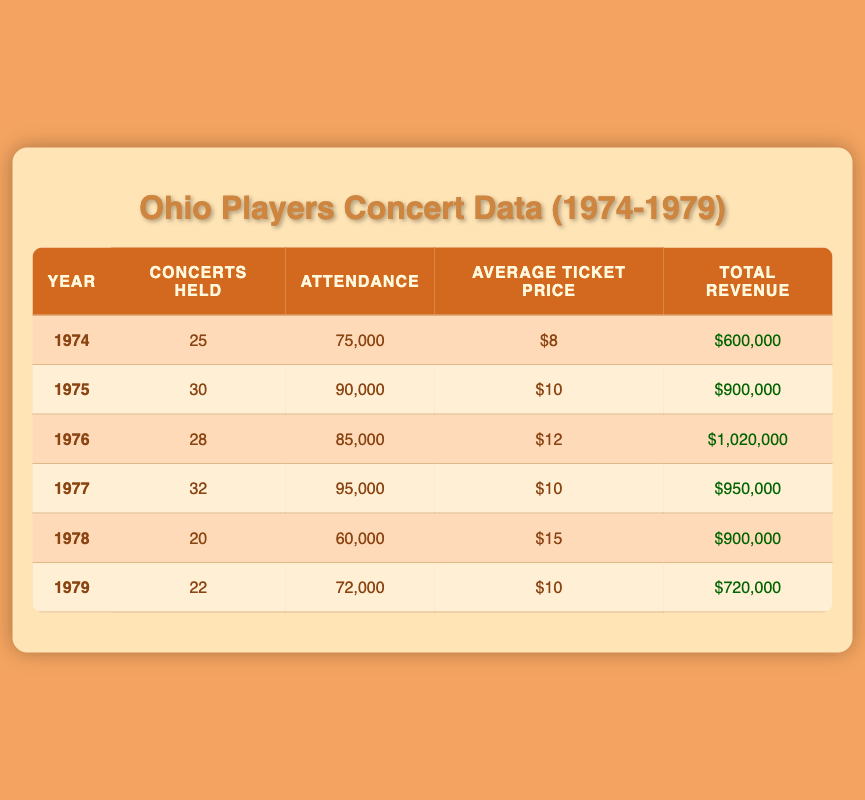What was the total attendance at Ohio Players concerts in 1975? The table shows that in 1975, the attendance was 90,000. I can directly refer to the corresponding cell in the "Attendance" column for the year 1975 to find this information.
Answer: 90,000 How much total revenue was generated in 1976? By looking at the table, I see that for the year 1976, the total revenue is listed as $1,020,000 in the "Total Revenue" column. I can directly refer to this cell to provide the answer.
Answer: $1,020,000 Which year had the highest average ticket price, and what was that price? I compare the average ticket prices across all years in the table. In 1978, the average ticket price is $15, which is higher than all other years. Thus, the year with the highest average ticket price is 1978, at $15.
Answer: 1978, $15 What is the total number of concerts held from 1974 to 1979? To get the total number of concerts held from 1974 to 1979, I sum the concerts held in each year: 25 + 30 + 28 + 32 + 20 + 22 = 157. Therefore, the total number of concerts held is 157.
Answer: 157 Was the attendance in 1977 greater than that in 1975? Looking at the attendance figures, 1977 has 95,000 attendees, while 1975 has 90,000. Since 95,000 is greater than 90,000, the statement is true.
Answer: Yes What was the average attendance per concert for 1978? I will find the average attendance per concert by dividing the total attendance in 1978 (60,000) by the number of concerts held that year (20). Calculation: 60,000 / 20 = 3,000. Hence, the average attendance per concert for 1978 is 3,000.
Answer: 3,000 Did the total revenue in 1979 exceed one million dollars? From the table, the total revenue for 1979 is shown as $720,000. Since $720,000 is less than one million, the statement is false.
Answer: No What was the percentage increase in total revenue from 1974 to 1976? First, I find the total revenue for 1974, which is $600,000, and for 1976, which is $1,020,000. The increase is $1,020,000 - $600,000 = $420,000. The percentage increase is then calculated as (420,000 / 600,000) * 100 = 70%. Hence, the percentage increase in total revenue from 1974 to 1976 is 70%.
Answer: 70% 